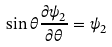<formula> <loc_0><loc_0><loc_500><loc_500>\sin \theta \frac { \partial \psi _ { 2 } } { \partial \theta } = \psi _ { 2 }</formula> 